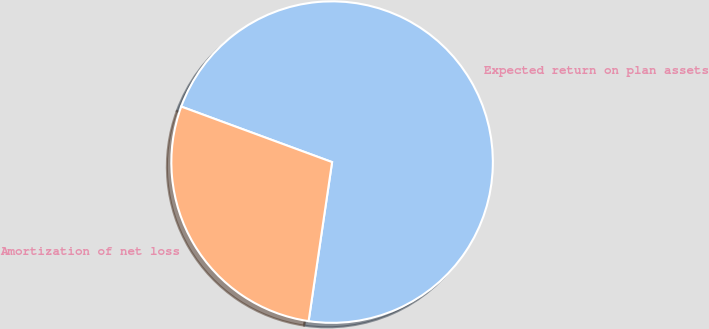Convert chart. <chart><loc_0><loc_0><loc_500><loc_500><pie_chart><fcel>Expected return on plan assets<fcel>Amortization of net loss<nl><fcel>71.72%<fcel>28.28%<nl></chart> 